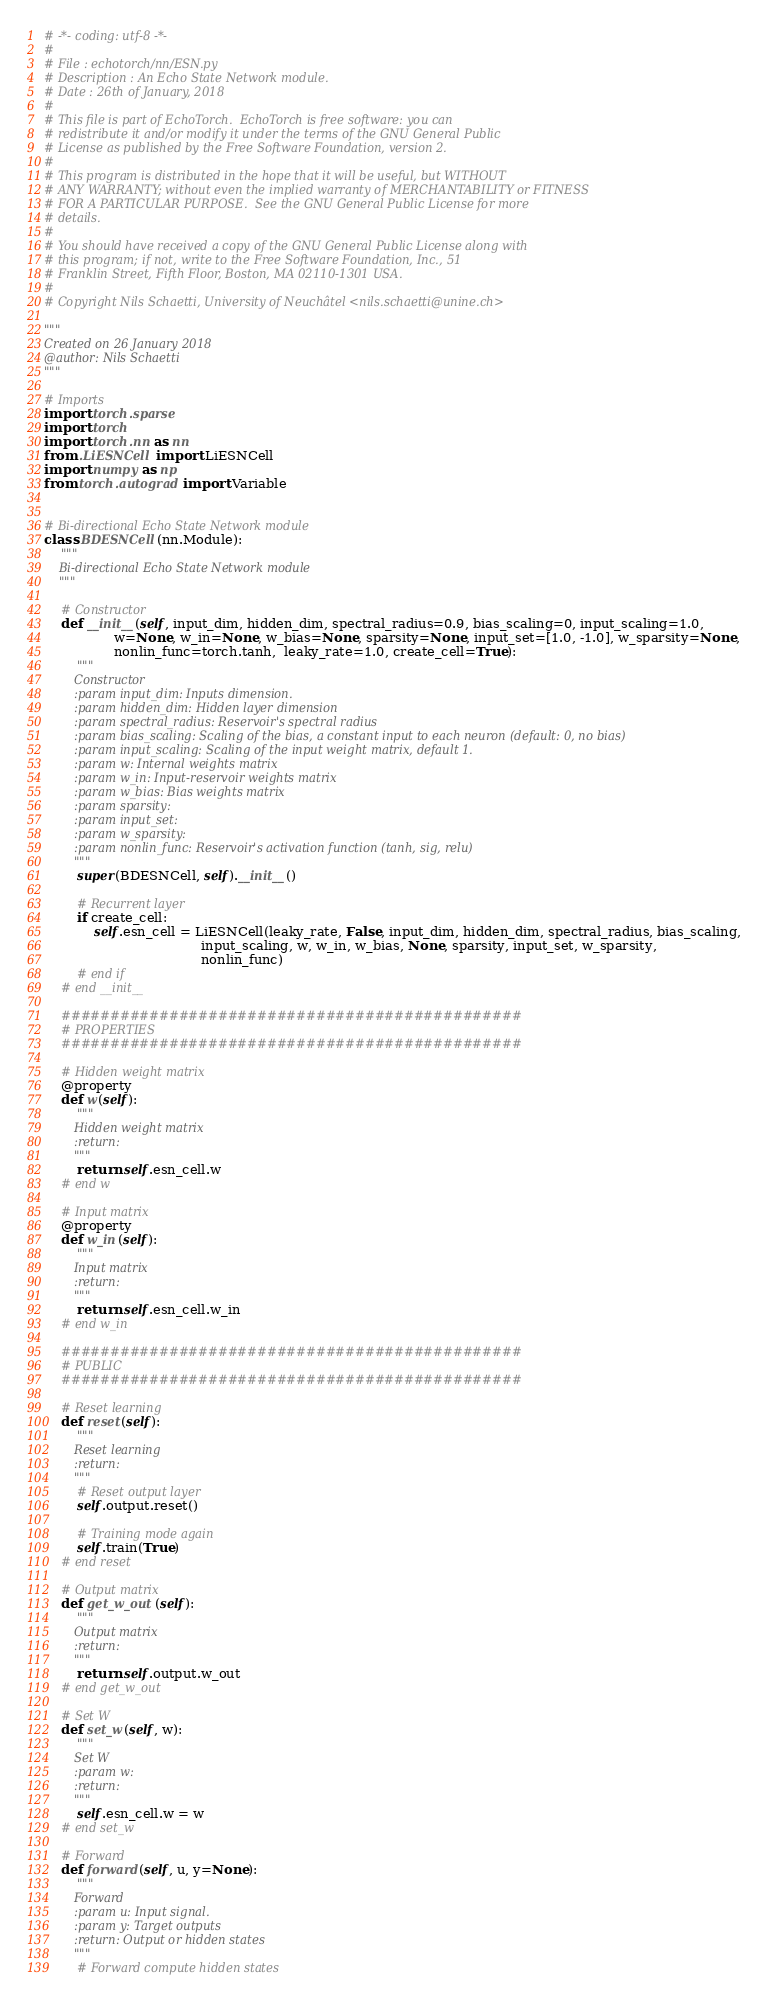Convert code to text. <code><loc_0><loc_0><loc_500><loc_500><_Python_># -*- coding: utf-8 -*-
#
# File : echotorch/nn/ESN.py
# Description : An Echo State Network module.
# Date : 26th of January, 2018
#
# This file is part of EchoTorch.  EchoTorch is free software: you can
# redistribute it and/or modify it under the terms of the GNU General Public
# License as published by the Free Software Foundation, version 2.
#
# This program is distributed in the hope that it will be useful, but WITHOUT
# ANY WARRANTY; without even the implied warranty of MERCHANTABILITY or FITNESS
# FOR A PARTICULAR PURPOSE.  See the GNU General Public License for more
# details.
#
# You should have received a copy of the GNU General Public License along with
# this program; if not, write to the Free Software Foundation, Inc., 51
# Franklin Street, Fifth Floor, Boston, MA 02110-1301 USA.
#
# Copyright Nils Schaetti, University of Neuchâtel <nils.schaetti@unine.ch>

"""
Created on 26 January 2018
@author: Nils Schaetti
"""

# Imports
import torch.sparse
import torch
import torch.nn as nn
from .LiESNCell import LiESNCell
import numpy as np
from torch.autograd import Variable


# Bi-directional Echo State Network module
class BDESNCell(nn.Module):
    """
    Bi-directional Echo State Network module
    """

    # Constructor
    def __init__(self, input_dim, hidden_dim, spectral_radius=0.9, bias_scaling=0, input_scaling=1.0,
                 w=None, w_in=None, w_bias=None, sparsity=None, input_set=[1.0, -1.0], w_sparsity=None,
                 nonlin_func=torch.tanh,  leaky_rate=1.0, create_cell=True):
        """
        Constructor
        :param input_dim: Inputs dimension.
        :param hidden_dim: Hidden layer dimension
        :param spectral_radius: Reservoir's spectral radius
        :param bias_scaling: Scaling of the bias, a constant input to each neuron (default: 0, no bias)
        :param input_scaling: Scaling of the input weight matrix, default 1.
        :param w: Internal weights matrix
        :param w_in: Input-reservoir weights matrix
        :param w_bias: Bias weights matrix
        :param sparsity:
        :param input_set:
        :param w_sparsity:
        :param nonlin_func: Reservoir's activation function (tanh, sig, relu)
        """
        super(BDESNCell, self).__init__()

        # Recurrent layer
        if create_cell:
            self.esn_cell = LiESNCell(leaky_rate, False, input_dim, hidden_dim, spectral_radius, bias_scaling,
                                      input_scaling, w, w_in, w_bias, None, sparsity, input_set, w_sparsity,
                                      nonlin_func)
        # end if
    # end __init__

    ###############################################
    # PROPERTIES
    ###############################################

    # Hidden weight matrix
    @property
    def w(self):
        """
        Hidden weight matrix
        :return:
        """
        return self.esn_cell.w
    # end w

    # Input matrix
    @property
    def w_in(self):
        """
        Input matrix
        :return:
        """
        return self.esn_cell.w_in
    # end w_in

    ###############################################
    # PUBLIC
    ###############################################

    # Reset learning
    def reset(self):
        """
        Reset learning
        :return:
        """
        # Reset output layer
        self.output.reset()

        # Training mode again
        self.train(True)
    # end reset

    # Output matrix
    def get_w_out(self):
        """
        Output matrix
        :return:
        """
        return self.output.w_out
    # end get_w_out

    # Set W
    def set_w(self, w):
        """
        Set W
        :param w:
        :return:
        """
        self.esn_cell.w = w
    # end set_w

    # Forward
    def forward(self, u, y=None):
        """
        Forward
        :param u: Input signal.
        :param y: Target outputs
        :return: Output or hidden states
        """
        # Forward compute hidden states</code> 